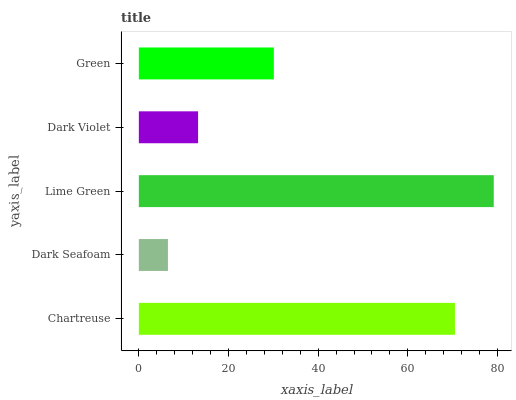Is Dark Seafoam the minimum?
Answer yes or no. Yes. Is Lime Green the maximum?
Answer yes or no. Yes. Is Lime Green the minimum?
Answer yes or no. No. Is Dark Seafoam the maximum?
Answer yes or no. No. Is Lime Green greater than Dark Seafoam?
Answer yes or no. Yes. Is Dark Seafoam less than Lime Green?
Answer yes or no. Yes. Is Dark Seafoam greater than Lime Green?
Answer yes or no. No. Is Lime Green less than Dark Seafoam?
Answer yes or no. No. Is Green the high median?
Answer yes or no. Yes. Is Green the low median?
Answer yes or no. Yes. Is Lime Green the high median?
Answer yes or no. No. Is Chartreuse the low median?
Answer yes or no. No. 